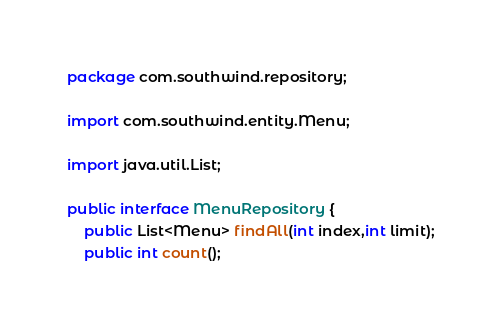<code> <loc_0><loc_0><loc_500><loc_500><_Java_>package com.southwind.repository;

import com.southwind.entity.Menu;

import java.util.List;

public interface MenuRepository {
    public List<Menu> findAll(int index,int limit);
    public int count();</code> 